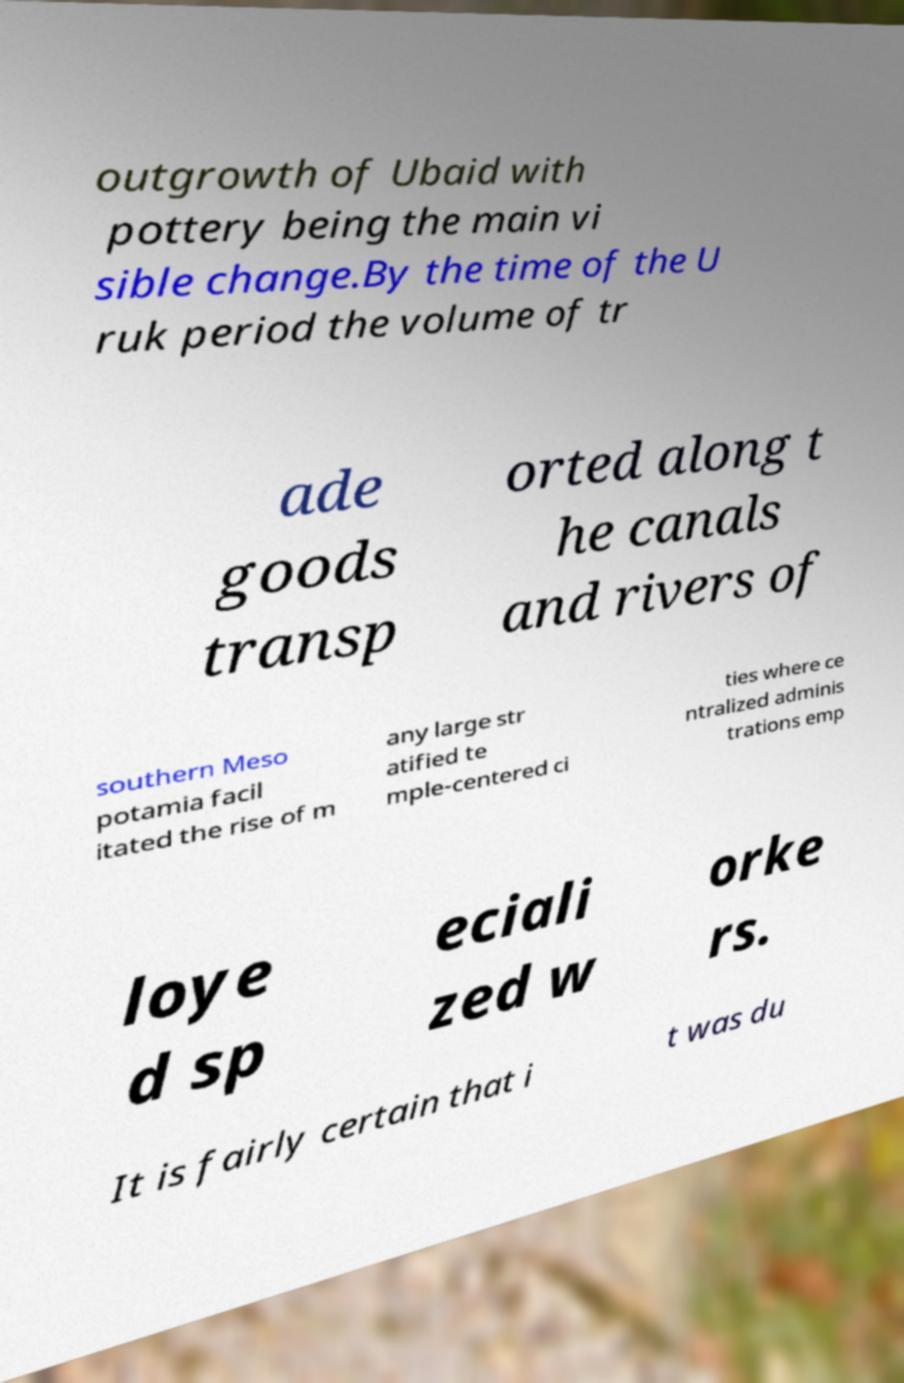Could you extract and type out the text from this image? outgrowth of Ubaid with pottery being the main vi sible change.By the time of the U ruk period the volume of tr ade goods transp orted along t he canals and rivers of southern Meso potamia facil itated the rise of m any large str atified te mple-centered ci ties where ce ntralized adminis trations emp loye d sp eciali zed w orke rs. It is fairly certain that i t was du 